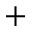Convert formula to latex. <formula><loc_0><loc_0><loc_500><loc_500>+</formula> 